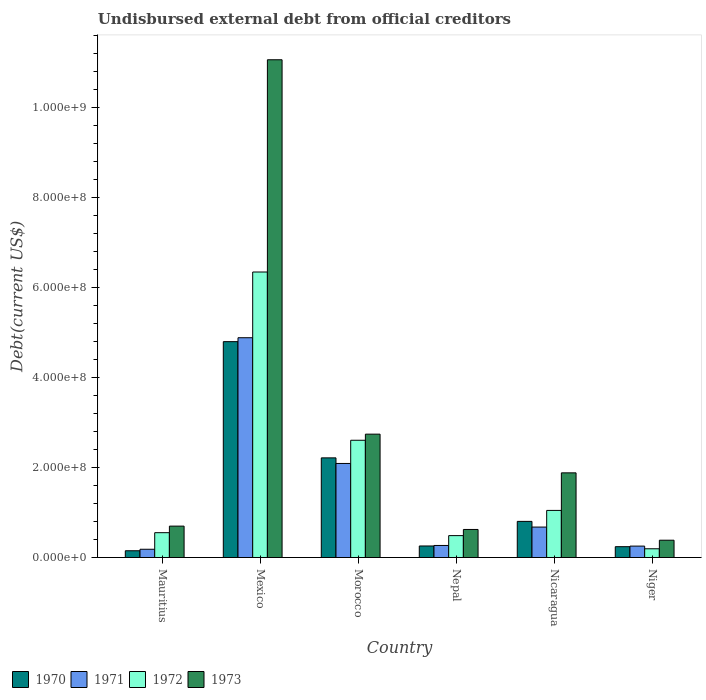How many different coloured bars are there?
Provide a short and direct response. 4. Are the number of bars per tick equal to the number of legend labels?
Give a very brief answer. Yes. How many bars are there on the 3rd tick from the left?
Your answer should be very brief. 4. How many bars are there on the 2nd tick from the right?
Your response must be concise. 4. What is the label of the 5th group of bars from the left?
Offer a terse response. Nicaragua. In how many cases, is the number of bars for a given country not equal to the number of legend labels?
Provide a short and direct response. 0. What is the total debt in 1972 in Niger?
Provide a succinct answer. 1.94e+07. Across all countries, what is the maximum total debt in 1973?
Your answer should be compact. 1.11e+09. Across all countries, what is the minimum total debt in 1971?
Ensure brevity in your answer.  1.84e+07. In which country was the total debt in 1972 minimum?
Your response must be concise. Niger. What is the total total debt in 1970 in the graph?
Your answer should be compact. 8.46e+08. What is the difference between the total debt in 1970 in Mauritius and that in Nicaragua?
Provide a short and direct response. -6.53e+07. What is the difference between the total debt in 1971 in Nicaragua and the total debt in 1973 in Niger?
Your response must be concise. 2.92e+07. What is the average total debt in 1971 per country?
Provide a succinct answer. 1.39e+08. What is the difference between the total debt of/in 1973 and total debt of/in 1971 in Morocco?
Offer a terse response. 6.51e+07. In how many countries, is the total debt in 1972 greater than 80000000 US$?
Keep it short and to the point. 3. What is the ratio of the total debt in 1973 in Nepal to that in Nicaragua?
Give a very brief answer. 0.33. Is the total debt in 1971 in Mauritius less than that in Mexico?
Offer a very short reply. Yes. Is the difference between the total debt in 1973 in Mexico and Morocco greater than the difference between the total debt in 1971 in Mexico and Morocco?
Offer a very short reply. Yes. What is the difference between the highest and the second highest total debt in 1973?
Your answer should be very brief. 8.32e+08. What is the difference between the highest and the lowest total debt in 1970?
Your answer should be compact. 4.65e+08. Is it the case that in every country, the sum of the total debt in 1971 and total debt in 1970 is greater than the sum of total debt in 1972 and total debt in 1973?
Offer a terse response. No. What does the 3rd bar from the right in Nicaragua represents?
Your answer should be very brief. 1971. Is it the case that in every country, the sum of the total debt in 1973 and total debt in 1970 is greater than the total debt in 1972?
Provide a succinct answer. Yes. How many countries are there in the graph?
Offer a very short reply. 6. What is the difference between two consecutive major ticks on the Y-axis?
Give a very brief answer. 2.00e+08. Are the values on the major ticks of Y-axis written in scientific E-notation?
Your answer should be very brief. Yes. Where does the legend appear in the graph?
Provide a succinct answer. Bottom left. How are the legend labels stacked?
Offer a very short reply. Horizontal. What is the title of the graph?
Ensure brevity in your answer.  Undisbursed external debt from official creditors. What is the label or title of the Y-axis?
Offer a terse response. Debt(current US$). What is the Debt(current US$) of 1970 in Mauritius?
Provide a short and direct response. 1.50e+07. What is the Debt(current US$) in 1971 in Mauritius?
Your answer should be very brief. 1.84e+07. What is the Debt(current US$) in 1972 in Mauritius?
Provide a short and direct response. 5.52e+07. What is the Debt(current US$) of 1973 in Mauritius?
Keep it short and to the point. 6.98e+07. What is the Debt(current US$) in 1970 in Mexico?
Make the answer very short. 4.80e+08. What is the Debt(current US$) in 1971 in Mexico?
Give a very brief answer. 4.88e+08. What is the Debt(current US$) of 1972 in Mexico?
Your response must be concise. 6.34e+08. What is the Debt(current US$) in 1973 in Mexico?
Your answer should be very brief. 1.11e+09. What is the Debt(current US$) of 1970 in Morocco?
Your response must be concise. 2.21e+08. What is the Debt(current US$) in 1971 in Morocco?
Your answer should be compact. 2.09e+08. What is the Debt(current US$) in 1972 in Morocco?
Offer a terse response. 2.61e+08. What is the Debt(current US$) in 1973 in Morocco?
Your response must be concise. 2.74e+08. What is the Debt(current US$) of 1970 in Nepal?
Provide a succinct answer. 2.57e+07. What is the Debt(current US$) of 1971 in Nepal?
Provide a short and direct response. 2.68e+07. What is the Debt(current US$) of 1972 in Nepal?
Provide a short and direct response. 4.87e+07. What is the Debt(current US$) of 1973 in Nepal?
Offer a terse response. 6.23e+07. What is the Debt(current US$) of 1970 in Nicaragua?
Your response must be concise. 8.03e+07. What is the Debt(current US$) of 1971 in Nicaragua?
Ensure brevity in your answer.  6.77e+07. What is the Debt(current US$) in 1972 in Nicaragua?
Give a very brief answer. 1.05e+08. What is the Debt(current US$) of 1973 in Nicaragua?
Give a very brief answer. 1.88e+08. What is the Debt(current US$) of 1970 in Niger?
Keep it short and to the point. 2.41e+07. What is the Debt(current US$) in 1971 in Niger?
Ensure brevity in your answer.  2.54e+07. What is the Debt(current US$) in 1972 in Niger?
Offer a terse response. 1.94e+07. What is the Debt(current US$) of 1973 in Niger?
Make the answer very short. 3.85e+07. Across all countries, what is the maximum Debt(current US$) in 1970?
Your response must be concise. 4.80e+08. Across all countries, what is the maximum Debt(current US$) in 1971?
Your answer should be compact. 4.88e+08. Across all countries, what is the maximum Debt(current US$) in 1972?
Your answer should be very brief. 6.34e+08. Across all countries, what is the maximum Debt(current US$) of 1973?
Your answer should be very brief. 1.11e+09. Across all countries, what is the minimum Debt(current US$) of 1970?
Provide a short and direct response. 1.50e+07. Across all countries, what is the minimum Debt(current US$) of 1971?
Provide a succinct answer. 1.84e+07. Across all countries, what is the minimum Debt(current US$) of 1972?
Your response must be concise. 1.94e+07. Across all countries, what is the minimum Debt(current US$) of 1973?
Ensure brevity in your answer.  3.85e+07. What is the total Debt(current US$) of 1970 in the graph?
Ensure brevity in your answer.  8.46e+08. What is the total Debt(current US$) of 1971 in the graph?
Ensure brevity in your answer.  8.36e+08. What is the total Debt(current US$) of 1972 in the graph?
Your answer should be very brief. 1.12e+09. What is the total Debt(current US$) of 1973 in the graph?
Ensure brevity in your answer.  1.74e+09. What is the difference between the Debt(current US$) of 1970 in Mauritius and that in Mexico?
Make the answer very short. -4.65e+08. What is the difference between the Debt(current US$) in 1971 in Mauritius and that in Mexico?
Offer a very short reply. -4.70e+08. What is the difference between the Debt(current US$) in 1972 in Mauritius and that in Mexico?
Your answer should be compact. -5.79e+08. What is the difference between the Debt(current US$) in 1973 in Mauritius and that in Mexico?
Ensure brevity in your answer.  -1.04e+09. What is the difference between the Debt(current US$) in 1970 in Mauritius and that in Morocco?
Your response must be concise. -2.06e+08. What is the difference between the Debt(current US$) of 1971 in Mauritius and that in Morocco?
Your answer should be very brief. -1.91e+08. What is the difference between the Debt(current US$) in 1972 in Mauritius and that in Morocco?
Your response must be concise. -2.05e+08. What is the difference between the Debt(current US$) in 1973 in Mauritius and that in Morocco?
Offer a terse response. -2.04e+08. What is the difference between the Debt(current US$) in 1970 in Mauritius and that in Nepal?
Your answer should be very brief. -1.06e+07. What is the difference between the Debt(current US$) of 1971 in Mauritius and that in Nepal?
Offer a very short reply. -8.45e+06. What is the difference between the Debt(current US$) in 1972 in Mauritius and that in Nepal?
Give a very brief answer. 6.54e+06. What is the difference between the Debt(current US$) in 1973 in Mauritius and that in Nepal?
Provide a succinct answer. 7.45e+06. What is the difference between the Debt(current US$) of 1970 in Mauritius and that in Nicaragua?
Provide a succinct answer. -6.53e+07. What is the difference between the Debt(current US$) of 1971 in Mauritius and that in Nicaragua?
Your answer should be compact. -4.93e+07. What is the difference between the Debt(current US$) in 1972 in Mauritius and that in Nicaragua?
Your answer should be very brief. -4.95e+07. What is the difference between the Debt(current US$) in 1973 in Mauritius and that in Nicaragua?
Make the answer very short. -1.18e+08. What is the difference between the Debt(current US$) in 1970 in Mauritius and that in Niger?
Your response must be concise. -9.05e+06. What is the difference between the Debt(current US$) in 1971 in Mauritius and that in Niger?
Ensure brevity in your answer.  -7.00e+06. What is the difference between the Debt(current US$) of 1972 in Mauritius and that in Niger?
Your answer should be compact. 3.58e+07. What is the difference between the Debt(current US$) of 1973 in Mauritius and that in Niger?
Your response must be concise. 3.13e+07. What is the difference between the Debt(current US$) in 1970 in Mexico and that in Morocco?
Provide a succinct answer. 2.58e+08. What is the difference between the Debt(current US$) of 1971 in Mexico and that in Morocco?
Give a very brief answer. 2.79e+08. What is the difference between the Debt(current US$) of 1972 in Mexico and that in Morocco?
Make the answer very short. 3.74e+08. What is the difference between the Debt(current US$) in 1973 in Mexico and that in Morocco?
Make the answer very short. 8.32e+08. What is the difference between the Debt(current US$) of 1970 in Mexico and that in Nepal?
Offer a very short reply. 4.54e+08. What is the difference between the Debt(current US$) in 1971 in Mexico and that in Nepal?
Offer a very short reply. 4.62e+08. What is the difference between the Debt(current US$) of 1972 in Mexico and that in Nepal?
Make the answer very short. 5.86e+08. What is the difference between the Debt(current US$) of 1973 in Mexico and that in Nepal?
Make the answer very short. 1.04e+09. What is the difference between the Debt(current US$) of 1970 in Mexico and that in Nicaragua?
Your answer should be very brief. 3.99e+08. What is the difference between the Debt(current US$) of 1971 in Mexico and that in Nicaragua?
Make the answer very short. 4.21e+08. What is the difference between the Debt(current US$) of 1972 in Mexico and that in Nicaragua?
Your answer should be compact. 5.30e+08. What is the difference between the Debt(current US$) in 1973 in Mexico and that in Nicaragua?
Make the answer very short. 9.18e+08. What is the difference between the Debt(current US$) in 1970 in Mexico and that in Niger?
Provide a short and direct response. 4.56e+08. What is the difference between the Debt(current US$) in 1971 in Mexico and that in Niger?
Offer a very short reply. 4.63e+08. What is the difference between the Debt(current US$) in 1972 in Mexico and that in Niger?
Provide a succinct answer. 6.15e+08. What is the difference between the Debt(current US$) of 1973 in Mexico and that in Niger?
Provide a succinct answer. 1.07e+09. What is the difference between the Debt(current US$) of 1970 in Morocco and that in Nepal?
Offer a terse response. 1.96e+08. What is the difference between the Debt(current US$) in 1971 in Morocco and that in Nepal?
Your answer should be compact. 1.82e+08. What is the difference between the Debt(current US$) of 1972 in Morocco and that in Nepal?
Offer a very short reply. 2.12e+08. What is the difference between the Debt(current US$) in 1973 in Morocco and that in Nepal?
Your response must be concise. 2.12e+08. What is the difference between the Debt(current US$) in 1970 in Morocco and that in Nicaragua?
Keep it short and to the point. 1.41e+08. What is the difference between the Debt(current US$) of 1971 in Morocco and that in Nicaragua?
Make the answer very short. 1.41e+08. What is the difference between the Debt(current US$) in 1972 in Morocco and that in Nicaragua?
Ensure brevity in your answer.  1.56e+08. What is the difference between the Debt(current US$) in 1973 in Morocco and that in Nicaragua?
Ensure brevity in your answer.  8.60e+07. What is the difference between the Debt(current US$) of 1970 in Morocco and that in Niger?
Keep it short and to the point. 1.97e+08. What is the difference between the Debt(current US$) of 1971 in Morocco and that in Niger?
Provide a succinct answer. 1.84e+08. What is the difference between the Debt(current US$) in 1972 in Morocco and that in Niger?
Provide a succinct answer. 2.41e+08. What is the difference between the Debt(current US$) of 1973 in Morocco and that in Niger?
Make the answer very short. 2.36e+08. What is the difference between the Debt(current US$) of 1970 in Nepal and that in Nicaragua?
Your answer should be very brief. -5.47e+07. What is the difference between the Debt(current US$) in 1971 in Nepal and that in Nicaragua?
Keep it short and to the point. -4.08e+07. What is the difference between the Debt(current US$) of 1972 in Nepal and that in Nicaragua?
Ensure brevity in your answer.  -5.60e+07. What is the difference between the Debt(current US$) of 1973 in Nepal and that in Nicaragua?
Ensure brevity in your answer.  -1.26e+08. What is the difference between the Debt(current US$) of 1970 in Nepal and that in Niger?
Provide a short and direct response. 1.55e+06. What is the difference between the Debt(current US$) of 1971 in Nepal and that in Niger?
Provide a short and direct response. 1.45e+06. What is the difference between the Debt(current US$) of 1972 in Nepal and that in Niger?
Give a very brief answer. 2.92e+07. What is the difference between the Debt(current US$) in 1973 in Nepal and that in Niger?
Ensure brevity in your answer.  2.39e+07. What is the difference between the Debt(current US$) of 1970 in Nicaragua and that in Niger?
Your response must be concise. 5.62e+07. What is the difference between the Debt(current US$) of 1971 in Nicaragua and that in Niger?
Your answer should be compact. 4.23e+07. What is the difference between the Debt(current US$) in 1972 in Nicaragua and that in Niger?
Provide a succinct answer. 8.52e+07. What is the difference between the Debt(current US$) in 1973 in Nicaragua and that in Niger?
Provide a short and direct response. 1.50e+08. What is the difference between the Debt(current US$) in 1970 in Mauritius and the Debt(current US$) in 1971 in Mexico?
Offer a terse response. -4.73e+08. What is the difference between the Debt(current US$) in 1970 in Mauritius and the Debt(current US$) in 1972 in Mexico?
Your answer should be compact. -6.19e+08. What is the difference between the Debt(current US$) in 1970 in Mauritius and the Debt(current US$) in 1973 in Mexico?
Provide a short and direct response. -1.09e+09. What is the difference between the Debt(current US$) of 1971 in Mauritius and the Debt(current US$) of 1972 in Mexico?
Provide a succinct answer. -6.16e+08. What is the difference between the Debt(current US$) in 1971 in Mauritius and the Debt(current US$) in 1973 in Mexico?
Ensure brevity in your answer.  -1.09e+09. What is the difference between the Debt(current US$) in 1972 in Mauritius and the Debt(current US$) in 1973 in Mexico?
Provide a short and direct response. -1.05e+09. What is the difference between the Debt(current US$) of 1970 in Mauritius and the Debt(current US$) of 1971 in Morocco?
Your answer should be compact. -1.94e+08. What is the difference between the Debt(current US$) in 1970 in Mauritius and the Debt(current US$) in 1972 in Morocco?
Your response must be concise. -2.45e+08. What is the difference between the Debt(current US$) in 1970 in Mauritius and the Debt(current US$) in 1973 in Morocco?
Make the answer very short. -2.59e+08. What is the difference between the Debt(current US$) of 1971 in Mauritius and the Debt(current US$) of 1972 in Morocco?
Your response must be concise. -2.42e+08. What is the difference between the Debt(current US$) in 1971 in Mauritius and the Debt(current US$) in 1973 in Morocco?
Offer a very short reply. -2.56e+08. What is the difference between the Debt(current US$) of 1972 in Mauritius and the Debt(current US$) of 1973 in Morocco?
Your answer should be compact. -2.19e+08. What is the difference between the Debt(current US$) of 1970 in Mauritius and the Debt(current US$) of 1971 in Nepal?
Your response must be concise. -1.18e+07. What is the difference between the Debt(current US$) of 1970 in Mauritius and the Debt(current US$) of 1972 in Nepal?
Give a very brief answer. -3.36e+07. What is the difference between the Debt(current US$) in 1970 in Mauritius and the Debt(current US$) in 1973 in Nepal?
Give a very brief answer. -4.73e+07. What is the difference between the Debt(current US$) of 1971 in Mauritius and the Debt(current US$) of 1972 in Nepal?
Give a very brief answer. -3.03e+07. What is the difference between the Debt(current US$) in 1971 in Mauritius and the Debt(current US$) in 1973 in Nepal?
Give a very brief answer. -4.40e+07. What is the difference between the Debt(current US$) of 1972 in Mauritius and the Debt(current US$) of 1973 in Nepal?
Give a very brief answer. -7.14e+06. What is the difference between the Debt(current US$) of 1970 in Mauritius and the Debt(current US$) of 1971 in Nicaragua?
Ensure brevity in your answer.  -5.26e+07. What is the difference between the Debt(current US$) of 1970 in Mauritius and the Debt(current US$) of 1972 in Nicaragua?
Your answer should be very brief. -8.96e+07. What is the difference between the Debt(current US$) in 1970 in Mauritius and the Debt(current US$) in 1973 in Nicaragua?
Provide a short and direct response. -1.73e+08. What is the difference between the Debt(current US$) of 1971 in Mauritius and the Debt(current US$) of 1972 in Nicaragua?
Keep it short and to the point. -8.63e+07. What is the difference between the Debt(current US$) in 1971 in Mauritius and the Debt(current US$) in 1973 in Nicaragua?
Your answer should be very brief. -1.70e+08. What is the difference between the Debt(current US$) in 1972 in Mauritius and the Debt(current US$) in 1973 in Nicaragua?
Your response must be concise. -1.33e+08. What is the difference between the Debt(current US$) of 1970 in Mauritius and the Debt(current US$) of 1971 in Niger?
Offer a terse response. -1.03e+07. What is the difference between the Debt(current US$) in 1970 in Mauritius and the Debt(current US$) in 1972 in Niger?
Provide a short and direct response. -4.40e+06. What is the difference between the Debt(current US$) in 1970 in Mauritius and the Debt(current US$) in 1973 in Niger?
Provide a succinct answer. -2.34e+07. What is the difference between the Debt(current US$) in 1971 in Mauritius and the Debt(current US$) in 1972 in Niger?
Offer a terse response. -1.08e+06. What is the difference between the Debt(current US$) of 1971 in Mauritius and the Debt(current US$) of 1973 in Niger?
Your response must be concise. -2.01e+07. What is the difference between the Debt(current US$) of 1972 in Mauritius and the Debt(current US$) of 1973 in Niger?
Keep it short and to the point. 1.67e+07. What is the difference between the Debt(current US$) of 1970 in Mexico and the Debt(current US$) of 1971 in Morocco?
Your response must be concise. 2.71e+08. What is the difference between the Debt(current US$) of 1970 in Mexico and the Debt(current US$) of 1972 in Morocco?
Keep it short and to the point. 2.19e+08. What is the difference between the Debt(current US$) of 1970 in Mexico and the Debt(current US$) of 1973 in Morocco?
Your response must be concise. 2.06e+08. What is the difference between the Debt(current US$) of 1971 in Mexico and the Debt(current US$) of 1972 in Morocco?
Give a very brief answer. 2.28e+08. What is the difference between the Debt(current US$) of 1971 in Mexico and the Debt(current US$) of 1973 in Morocco?
Your answer should be compact. 2.14e+08. What is the difference between the Debt(current US$) in 1972 in Mexico and the Debt(current US$) in 1973 in Morocco?
Your answer should be very brief. 3.60e+08. What is the difference between the Debt(current US$) in 1970 in Mexico and the Debt(current US$) in 1971 in Nepal?
Keep it short and to the point. 4.53e+08. What is the difference between the Debt(current US$) in 1970 in Mexico and the Debt(current US$) in 1972 in Nepal?
Keep it short and to the point. 4.31e+08. What is the difference between the Debt(current US$) in 1970 in Mexico and the Debt(current US$) in 1973 in Nepal?
Provide a succinct answer. 4.17e+08. What is the difference between the Debt(current US$) in 1971 in Mexico and the Debt(current US$) in 1972 in Nepal?
Offer a terse response. 4.40e+08. What is the difference between the Debt(current US$) of 1971 in Mexico and the Debt(current US$) of 1973 in Nepal?
Provide a short and direct response. 4.26e+08. What is the difference between the Debt(current US$) of 1972 in Mexico and the Debt(current US$) of 1973 in Nepal?
Give a very brief answer. 5.72e+08. What is the difference between the Debt(current US$) of 1970 in Mexico and the Debt(current US$) of 1971 in Nicaragua?
Make the answer very short. 4.12e+08. What is the difference between the Debt(current US$) of 1970 in Mexico and the Debt(current US$) of 1972 in Nicaragua?
Offer a terse response. 3.75e+08. What is the difference between the Debt(current US$) in 1970 in Mexico and the Debt(current US$) in 1973 in Nicaragua?
Keep it short and to the point. 2.92e+08. What is the difference between the Debt(current US$) of 1971 in Mexico and the Debt(current US$) of 1972 in Nicaragua?
Your response must be concise. 3.84e+08. What is the difference between the Debt(current US$) of 1971 in Mexico and the Debt(current US$) of 1973 in Nicaragua?
Your response must be concise. 3.00e+08. What is the difference between the Debt(current US$) of 1972 in Mexico and the Debt(current US$) of 1973 in Nicaragua?
Your answer should be very brief. 4.46e+08. What is the difference between the Debt(current US$) in 1970 in Mexico and the Debt(current US$) in 1971 in Niger?
Your answer should be compact. 4.54e+08. What is the difference between the Debt(current US$) in 1970 in Mexico and the Debt(current US$) in 1972 in Niger?
Make the answer very short. 4.60e+08. What is the difference between the Debt(current US$) in 1970 in Mexico and the Debt(current US$) in 1973 in Niger?
Your response must be concise. 4.41e+08. What is the difference between the Debt(current US$) in 1971 in Mexico and the Debt(current US$) in 1972 in Niger?
Your answer should be very brief. 4.69e+08. What is the difference between the Debt(current US$) in 1971 in Mexico and the Debt(current US$) in 1973 in Niger?
Offer a very short reply. 4.50e+08. What is the difference between the Debt(current US$) in 1972 in Mexico and the Debt(current US$) in 1973 in Niger?
Provide a succinct answer. 5.96e+08. What is the difference between the Debt(current US$) of 1970 in Morocco and the Debt(current US$) of 1971 in Nepal?
Offer a very short reply. 1.95e+08. What is the difference between the Debt(current US$) of 1970 in Morocco and the Debt(current US$) of 1972 in Nepal?
Your answer should be compact. 1.73e+08. What is the difference between the Debt(current US$) of 1970 in Morocco and the Debt(current US$) of 1973 in Nepal?
Give a very brief answer. 1.59e+08. What is the difference between the Debt(current US$) in 1971 in Morocco and the Debt(current US$) in 1972 in Nepal?
Ensure brevity in your answer.  1.60e+08. What is the difference between the Debt(current US$) in 1971 in Morocco and the Debt(current US$) in 1973 in Nepal?
Your answer should be very brief. 1.47e+08. What is the difference between the Debt(current US$) of 1972 in Morocco and the Debt(current US$) of 1973 in Nepal?
Provide a short and direct response. 1.98e+08. What is the difference between the Debt(current US$) in 1970 in Morocco and the Debt(current US$) in 1971 in Nicaragua?
Offer a terse response. 1.54e+08. What is the difference between the Debt(current US$) in 1970 in Morocco and the Debt(current US$) in 1972 in Nicaragua?
Ensure brevity in your answer.  1.17e+08. What is the difference between the Debt(current US$) in 1970 in Morocco and the Debt(current US$) in 1973 in Nicaragua?
Offer a terse response. 3.33e+07. What is the difference between the Debt(current US$) in 1971 in Morocco and the Debt(current US$) in 1972 in Nicaragua?
Make the answer very short. 1.04e+08. What is the difference between the Debt(current US$) in 1971 in Morocco and the Debt(current US$) in 1973 in Nicaragua?
Offer a terse response. 2.09e+07. What is the difference between the Debt(current US$) of 1972 in Morocco and the Debt(current US$) of 1973 in Nicaragua?
Offer a terse response. 7.24e+07. What is the difference between the Debt(current US$) of 1970 in Morocco and the Debt(current US$) of 1971 in Niger?
Provide a succinct answer. 1.96e+08. What is the difference between the Debt(current US$) in 1970 in Morocco and the Debt(current US$) in 1972 in Niger?
Your answer should be very brief. 2.02e+08. What is the difference between the Debt(current US$) in 1970 in Morocco and the Debt(current US$) in 1973 in Niger?
Keep it short and to the point. 1.83e+08. What is the difference between the Debt(current US$) in 1971 in Morocco and the Debt(current US$) in 1972 in Niger?
Ensure brevity in your answer.  1.90e+08. What is the difference between the Debt(current US$) in 1971 in Morocco and the Debt(current US$) in 1973 in Niger?
Give a very brief answer. 1.71e+08. What is the difference between the Debt(current US$) in 1972 in Morocco and the Debt(current US$) in 1973 in Niger?
Provide a short and direct response. 2.22e+08. What is the difference between the Debt(current US$) of 1970 in Nepal and the Debt(current US$) of 1971 in Nicaragua?
Offer a very short reply. -4.20e+07. What is the difference between the Debt(current US$) in 1970 in Nepal and the Debt(current US$) in 1972 in Nicaragua?
Provide a short and direct response. -7.90e+07. What is the difference between the Debt(current US$) of 1970 in Nepal and the Debt(current US$) of 1973 in Nicaragua?
Your response must be concise. -1.62e+08. What is the difference between the Debt(current US$) of 1971 in Nepal and the Debt(current US$) of 1972 in Nicaragua?
Ensure brevity in your answer.  -7.78e+07. What is the difference between the Debt(current US$) of 1971 in Nepal and the Debt(current US$) of 1973 in Nicaragua?
Keep it short and to the point. -1.61e+08. What is the difference between the Debt(current US$) in 1972 in Nepal and the Debt(current US$) in 1973 in Nicaragua?
Your response must be concise. -1.39e+08. What is the difference between the Debt(current US$) of 1970 in Nepal and the Debt(current US$) of 1971 in Niger?
Give a very brief answer. 2.78e+05. What is the difference between the Debt(current US$) of 1970 in Nepal and the Debt(current US$) of 1972 in Niger?
Offer a very short reply. 6.20e+06. What is the difference between the Debt(current US$) in 1970 in Nepal and the Debt(current US$) in 1973 in Niger?
Your response must be concise. -1.28e+07. What is the difference between the Debt(current US$) in 1971 in Nepal and the Debt(current US$) in 1972 in Niger?
Your response must be concise. 7.37e+06. What is the difference between the Debt(current US$) in 1971 in Nepal and the Debt(current US$) in 1973 in Niger?
Provide a succinct answer. -1.17e+07. What is the difference between the Debt(current US$) in 1972 in Nepal and the Debt(current US$) in 1973 in Niger?
Keep it short and to the point. 1.02e+07. What is the difference between the Debt(current US$) of 1970 in Nicaragua and the Debt(current US$) of 1971 in Niger?
Offer a terse response. 5.49e+07. What is the difference between the Debt(current US$) of 1970 in Nicaragua and the Debt(current US$) of 1972 in Niger?
Give a very brief answer. 6.09e+07. What is the difference between the Debt(current US$) of 1970 in Nicaragua and the Debt(current US$) of 1973 in Niger?
Provide a short and direct response. 4.18e+07. What is the difference between the Debt(current US$) in 1971 in Nicaragua and the Debt(current US$) in 1972 in Niger?
Your answer should be very brief. 4.82e+07. What is the difference between the Debt(current US$) in 1971 in Nicaragua and the Debt(current US$) in 1973 in Niger?
Your answer should be compact. 2.92e+07. What is the difference between the Debt(current US$) in 1972 in Nicaragua and the Debt(current US$) in 1973 in Niger?
Make the answer very short. 6.62e+07. What is the average Debt(current US$) in 1970 per country?
Provide a succinct answer. 1.41e+08. What is the average Debt(current US$) of 1971 per country?
Provide a succinct answer. 1.39e+08. What is the average Debt(current US$) of 1972 per country?
Give a very brief answer. 1.87e+08. What is the average Debt(current US$) in 1973 per country?
Keep it short and to the point. 2.90e+08. What is the difference between the Debt(current US$) of 1970 and Debt(current US$) of 1971 in Mauritius?
Make the answer very short. -3.32e+06. What is the difference between the Debt(current US$) of 1970 and Debt(current US$) of 1972 in Mauritius?
Give a very brief answer. -4.02e+07. What is the difference between the Debt(current US$) in 1970 and Debt(current US$) in 1973 in Mauritius?
Provide a short and direct response. -5.47e+07. What is the difference between the Debt(current US$) in 1971 and Debt(current US$) in 1972 in Mauritius?
Ensure brevity in your answer.  -3.68e+07. What is the difference between the Debt(current US$) of 1971 and Debt(current US$) of 1973 in Mauritius?
Offer a very short reply. -5.14e+07. What is the difference between the Debt(current US$) of 1972 and Debt(current US$) of 1973 in Mauritius?
Ensure brevity in your answer.  -1.46e+07. What is the difference between the Debt(current US$) in 1970 and Debt(current US$) in 1971 in Mexico?
Offer a very short reply. -8.70e+06. What is the difference between the Debt(current US$) in 1970 and Debt(current US$) in 1972 in Mexico?
Offer a very short reply. -1.55e+08. What is the difference between the Debt(current US$) in 1970 and Debt(current US$) in 1973 in Mexico?
Give a very brief answer. -6.26e+08. What is the difference between the Debt(current US$) in 1971 and Debt(current US$) in 1972 in Mexico?
Provide a short and direct response. -1.46e+08. What is the difference between the Debt(current US$) in 1971 and Debt(current US$) in 1973 in Mexico?
Ensure brevity in your answer.  -6.18e+08. What is the difference between the Debt(current US$) of 1972 and Debt(current US$) of 1973 in Mexico?
Provide a succinct answer. -4.72e+08. What is the difference between the Debt(current US$) in 1970 and Debt(current US$) in 1971 in Morocco?
Keep it short and to the point. 1.24e+07. What is the difference between the Debt(current US$) of 1970 and Debt(current US$) of 1972 in Morocco?
Your response must be concise. -3.91e+07. What is the difference between the Debt(current US$) of 1970 and Debt(current US$) of 1973 in Morocco?
Keep it short and to the point. -5.27e+07. What is the difference between the Debt(current US$) of 1971 and Debt(current US$) of 1972 in Morocco?
Keep it short and to the point. -5.15e+07. What is the difference between the Debt(current US$) in 1971 and Debt(current US$) in 1973 in Morocco?
Provide a short and direct response. -6.51e+07. What is the difference between the Debt(current US$) of 1972 and Debt(current US$) of 1973 in Morocco?
Make the answer very short. -1.36e+07. What is the difference between the Debt(current US$) of 1970 and Debt(current US$) of 1971 in Nepal?
Give a very brief answer. -1.17e+06. What is the difference between the Debt(current US$) of 1970 and Debt(current US$) of 1972 in Nepal?
Keep it short and to the point. -2.30e+07. What is the difference between the Debt(current US$) in 1970 and Debt(current US$) in 1973 in Nepal?
Offer a very short reply. -3.67e+07. What is the difference between the Debt(current US$) of 1971 and Debt(current US$) of 1972 in Nepal?
Your answer should be very brief. -2.18e+07. What is the difference between the Debt(current US$) in 1971 and Debt(current US$) in 1973 in Nepal?
Make the answer very short. -3.55e+07. What is the difference between the Debt(current US$) in 1972 and Debt(current US$) in 1973 in Nepal?
Make the answer very short. -1.37e+07. What is the difference between the Debt(current US$) in 1970 and Debt(current US$) in 1971 in Nicaragua?
Provide a succinct answer. 1.26e+07. What is the difference between the Debt(current US$) of 1970 and Debt(current US$) of 1972 in Nicaragua?
Give a very brief answer. -2.44e+07. What is the difference between the Debt(current US$) in 1970 and Debt(current US$) in 1973 in Nicaragua?
Provide a short and direct response. -1.08e+08. What is the difference between the Debt(current US$) in 1971 and Debt(current US$) in 1972 in Nicaragua?
Offer a very short reply. -3.70e+07. What is the difference between the Debt(current US$) of 1971 and Debt(current US$) of 1973 in Nicaragua?
Your answer should be compact. -1.20e+08. What is the difference between the Debt(current US$) of 1972 and Debt(current US$) of 1973 in Nicaragua?
Your answer should be very brief. -8.35e+07. What is the difference between the Debt(current US$) in 1970 and Debt(current US$) in 1971 in Niger?
Ensure brevity in your answer.  -1.28e+06. What is the difference between the Debt(current US$) of 1970 and Debt(current US$) of 1972 in Niger?
Your answer should be compact. 4.65e+06. What is the difference between the Debt(current US$) of 1970 and Debt(current US$) of 1973 in Niger?
Provide a succinct answer. -1.44e+07. What is the difference between the Debt(current US$) of 1971 and Debt(current US$) of 1972 in Niger?
Your response must be concise. 5.93e+06. What is the difference between the Debt(current US$) in 1971 and Debt(current US$) in 1973 in Niger?
Offer a very short reply. -1.31e+07. What is the difference between the Debt(current US$) of 1972 and Debt(current US$) of 1973 in Niger?
Your answer should be very brief. -1.90e+07. What is the ratio of the Debt(current US$) in 1970 in Mauritius to that in Mexico?
Provide a succinct answer. 0.03. What is the ratio of the Debt(current US$) in 1971 in Mauritius to that in Mexico?
Keep it short and to the point. 0.04. What is the ratio of the Debt(current US$) of 1972 in Mauritius to that in Mexico?
Your response must be concise. 0.09. What is the ratio of the Debt(current US$) in 1973 in Mauritius to that in Mexico?
Keep it short and to the point. 0.06. What is the ratio of the Debt(current US$) in 1970 in Mauritius to that in Morocco?
Give a very brief answer. 0.07. What is the ratio of the Debt(current US$) in 1971 in Mauritius to that in Morocco?
Provide a succinct answer. 0.09. What is the ratio of the Debt(current US$) of 1972 in Mauritius to that in Morocco?
Make the answer very short. 0.21. What is the ratio of the Debt(current US$) of 1973 in Mauritius to that in Morocco?
Ensure brevity in your answer.  0.25. What is the ratio of the Debt(current US$) of 1970 in Mauritius to that in Nepal?
Make the answer very short. 0.59. What is the ratio of the Debt(current US$) of 1971 in Mauritius to that in Nepal?
Provide a succinct answer. 0.68. What is the ratio of the Debt(current US$) of 1972 in Mauritius to that in Nepal?
Make the answer very short. 1.13. What is the ratio of the Debt(current US$) of 1973 in Mauritius to that in Nepal?
Offer a terse response. 1.12. What is the ratio of the Debt(current US$) of 1970 in Mauritius to that in Nicaragua?
Offer a terse response. 0.19. What is the ratio of the Debt(current US$) in 1971 in Mauritius to that in Nicaragua?
Your response must be concise. 0.27. What is the ratio of the Debt(current US$) in 1972 in Mauritius to that in Nicaragua?
Give a very brief answer. 0.53. What is the ratio of the Debt(current US$) of 1973 in Mauritius to that in Nicaragua?
Your answer should be compact. 0.37. What is the ratio of the Debt(current US$) of 1970 in Mauritius to that in Niger?
Keep it short and to the point. 0.62. What is the ratio of the Debt(current US$) of 1971 in Mauritius to that in Niger?
Your response must be concise. 0.72. What is the ratio of the Debt(current US$) of 1972 in Mauritius to that in Niger?
Ensure brevity in your answer.  2.84. What is the ratio of the Debt(current US$) in 1973 in Mauritius to that in Niger?
Your response must be concise. 1.81. What is the ratio of the Debt(current US$) of 1970 in Mexico to that in Morocco?
Make the answer very short. 2.17. What is the ratio of the Debt(current US$) of 1971 in Mexico to that in Morocco?
Ensure brevity in your answer.  2.34. What is the ratio of the Debt(current US$) of 1972 in Mexico to that in Morocco?
Keep it short and to the point. 2.43. What is the ratio of the Debt(current US$) in 1973 in Mexico to that in Morocco?
Offer a very short reply. 4.03. What is the ratio of the Debt(current US$) in 1970 in Mexico to that in Nepal?
Make the answer very short. 18.7. What is the ratio of the Debt(current US$) of 1971 in Mexico to that in Nepal?
Provide a succinct answer. 18.21. What is the ratio of the Debt(current US$) of 1972 in Mexico to that in Nepal?
Give a very brief answer. 13.04. What is the ratio of the Debt(current US$) in 1973 in Mexico to that in Nepal?
Offer a terse response. 17.74. What is the ratio of the Debt(current US$) in 1970 in Mexico to that in Nicaragua?
Offer a very short reply. 5.97. What is the ratio of the Debt(current US$) in 1971 in Mexico to that in Nicaragua?
Make the answer very short. 7.22. What is the ratio of the Debt(current US$) of 1972 in Mexico to that in Nicaragua?
Your answer should be very brief. 6.06. What is the ratio of the Debt(current US$) in 1973 in Mexico to that in Nicaragua?
Make the answer very short. 5.88. What is the ratio of the Debt(current US$) of 1970 in Mexico to that in Niger?
Offer a terse response. 19.9. What is the ratio of the Debt(current US$) of 1971 in Mexico to that in Niger?
Your response must be concise. 19.25. What is the ratio of the Debt(current US$) in 1972 in Mexico to that in Niger?
Offer a terse response. 32.62. What is the ratio of the Debt(current US$) in 1973 in Mexico to that in Niger?
Provide a short and direct response. 28.74. What is the ratio of the Debt(current US$) of 1970 in Morocco to that in Nepal?
Make the answer very short. 8.63. What is the ratio of the Debt(current US$) in 1971 in Morocco to that in Nepal?
Give a very brief answer. 7.79. What is the ratio of the Debt(current US$) in 1972 in Morocco to that in Nepal?
Offer a very short reply. 5.35. What is the ratio of the Debt(current US$) in 1973 in Morocco to that in Nepal?
Give a very brief answer. 4.4. What is the ratio of the Debt(current US$) in 1970 in Morocco to that in Nicaragua?
Ensure brevity in your answer.  2.76. What is the ratio of the Debt(current US$) of 1971 in Morocco to that in Nicaragua?
Give a very brief answer. 3.09. What is the ratio of the Debt(current US$) of 1972 in Morocco to that in Nicaragua?
Your answer should be very brief. 2.49. What is the ratio of the Debt(current US$) of 1973 in Morocco to that in Nicaragua?
Give a very brief answer. 1.46. What is the ratio of the Debt(current US$) in 1970 in Morocco to that in Niger?
Offer a terse response. 9.19. What is the ratio of the Debt(current US$) in 1971 in Morocco to that in Niger?
Your answer should be compact. 8.24. What is the ratio of the Debt(current US$) of 1972 in Morocco to that in Niger?
Your response must be concise. 13.4. What is the ratio of the Debt(current US$) in 1973 in Morocco to that in Niger?
Offer a very short reply. 7.12. What is the ratio of the Debt(current US$) of 1970 in Nepal to that in Nicaragua?
Offer a very short reply. 0.32. What is the ratio of the Debt(current US$) in 1971 in Nepal to that in Nicaragua?
Ensure brevity in your answer.  0.4. What is the ratio of the Debt(current US$) of 1972 in Nepal to that in Nicaragua?
Your answer should be very brief. 0.46. What is the ratio of the Debt(current US$) in 1973 in Nepal to that in Nicaragua?
Ensure brevity in your answer.  0.33. What is the ratio of the Debt(current US$) in 1970 in Nepal to that in Niger?
Give a very brief answer. 1.06. What is the ratio of the Debt(current US$) in 1971 in Nepal to that in Niger?
Offer a terse response. 1.06. What is the ratio of the Debt(current US$) in 1972 in Nepal to that in Niger?
Your answer should be very brief. 2.5. What is the ratio of the Debt(current US$) in 1973 in Nepal to that in Niger?
Give a very brief answer. 1.62. What is the ratio of the Debt(current US$) in 1970 in Nicaragua to that in Niger?
Provide a succinct answer. 3.33. What is the ratio of the Debt(current US$) of 1971 in Nicaragua to that in Niger?
Provide a succinct answer. 2.67. What is the ratio of the Debt(current US$) of 1972 in Nicaragua to that in Niger?
Your response must be concise. 5.38. What is the ratio of the Debt(current US$) of 1973 in Nicaragua to that in Niger?
Your answer should be compact. 4.89. What is the difference between the highest and the second highest Debt(current US$) in 1970?
Make the answer very short. 2.58e+08. What is the difference between the highest and the second highest Debt(current US$) in 1971?
Offer a very short reply. 2.79e+08. What is the difference between the highest and the second highest Debt(current US$) of 1972?
Provide a succinct answer. 3.74e+08. What is the difference between the highest and the second highest Debt(current US$) in 1973?
Your response must be concise. 8.32e+08. What is the difference between the highest and the lowest Debt(current US$) of 1970?
Offer a very short reply. 4.65e+08. What is the difference between the highest and the lowest Debt(current US$) in 1971?
Keep it short and to the point. 4.70e+08. What is the difference between the highest and the lowest Debt(current US$) in 1972?
Your answer should be compact. 6.15e+08. What is the difference between the highest and the lowest Debt(current US$) of 1973?
Provide a succinct answer. 1.07e+09. 